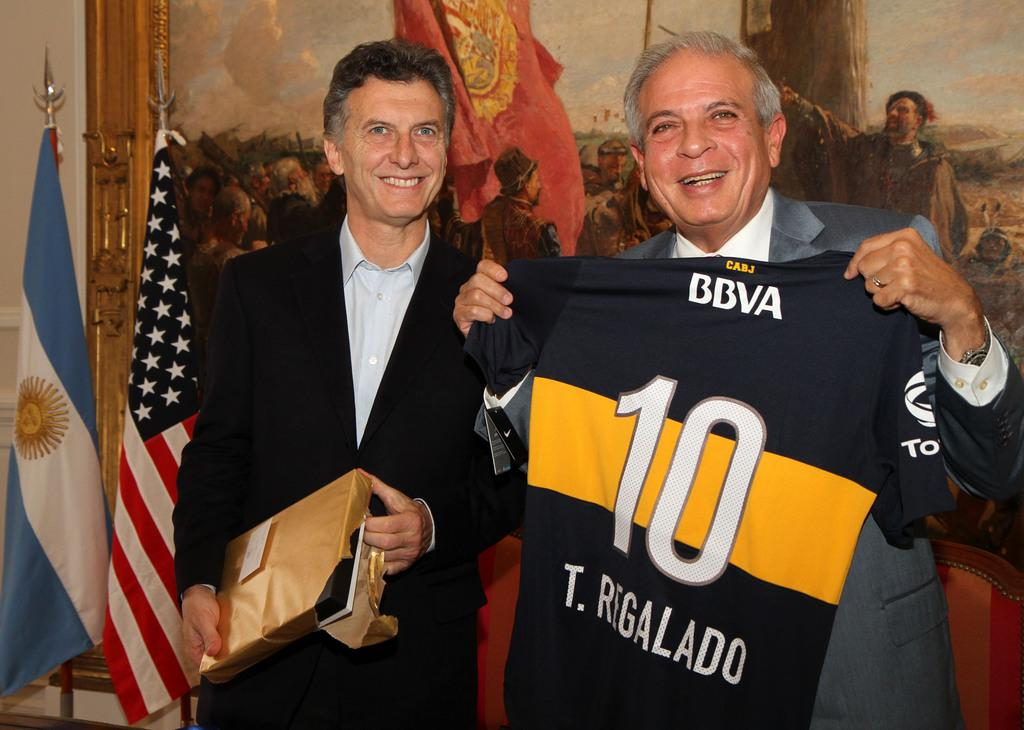<image>
Create a compact narrative representing the image presented. Man holding a jersey that has the number 10 on it. 